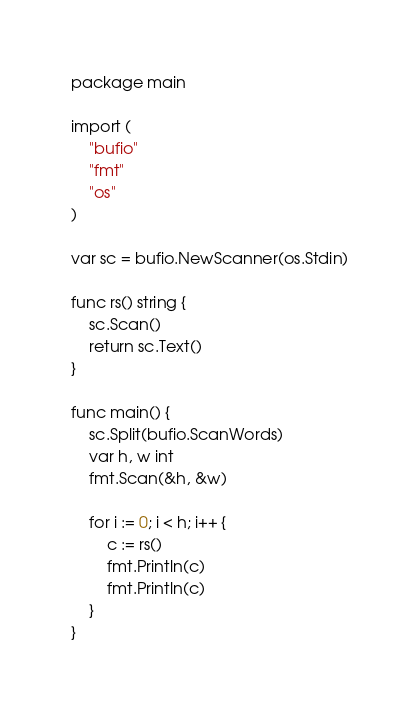<code> <loc_0><loc_0><loc_500><loc_500><_Go_>package main

import (
	"bufio"
	"fmt"
	"os"
)

var sc = bufio.NewScanner(os.Stdin)

func rs() string {
	sc.Scan()
	return sc.Text()
}

func main() {
	sc.Split(bufio.ScanWords)
	var h, w int
	fmt.Scan(&h, &w)

	for i := 0; i < h; i++ {
		c := rs()
		fmt.Println(c)
		fmt.Println(c)
	}
}
</code> 